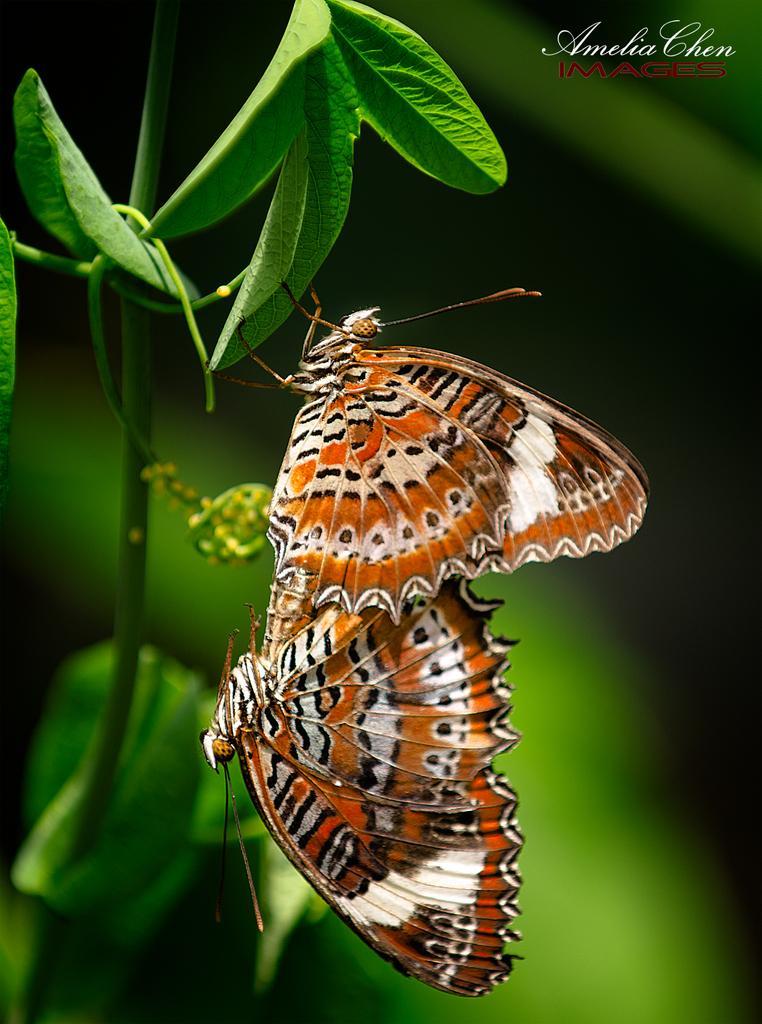How would you summarize this image in a sentence or two? This picture shows couple of butterflies on the leaf and we see text on the top right corner of a tree. 